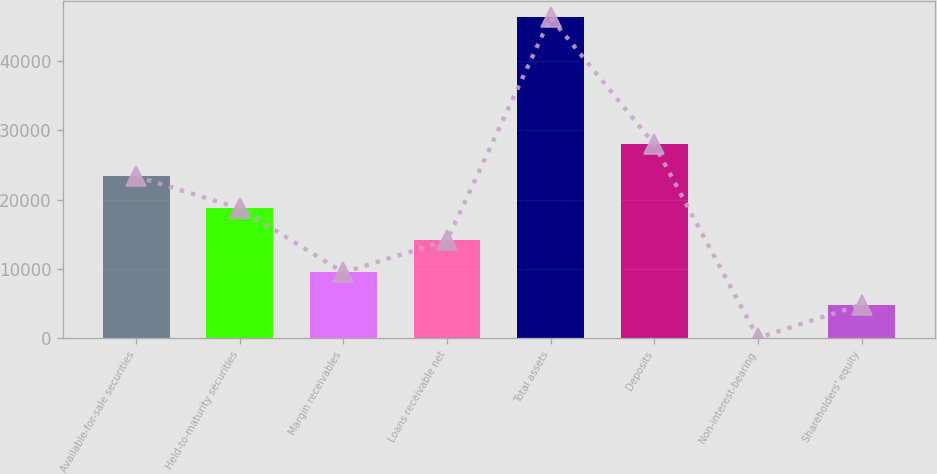Convert chart. <chart><loc_0><loc_0><loc_500><loc_500><bar_chart><fcel>Available-for-sale securities<fcel>Held-to-maturity securities<fcel>Margin receivables<fcel>Loans receivable net<fcel>Total assets<fcel>Deposits<fcel>Non-interest-bearing<fcel>Shareholders' equity<nl><fcel>23351.2<fcel>18727.4<fcel>9479.8<fcel>14103.6<fcel>46280<fcel>27975<fcel>42<fcel>4856<nl></chart> 